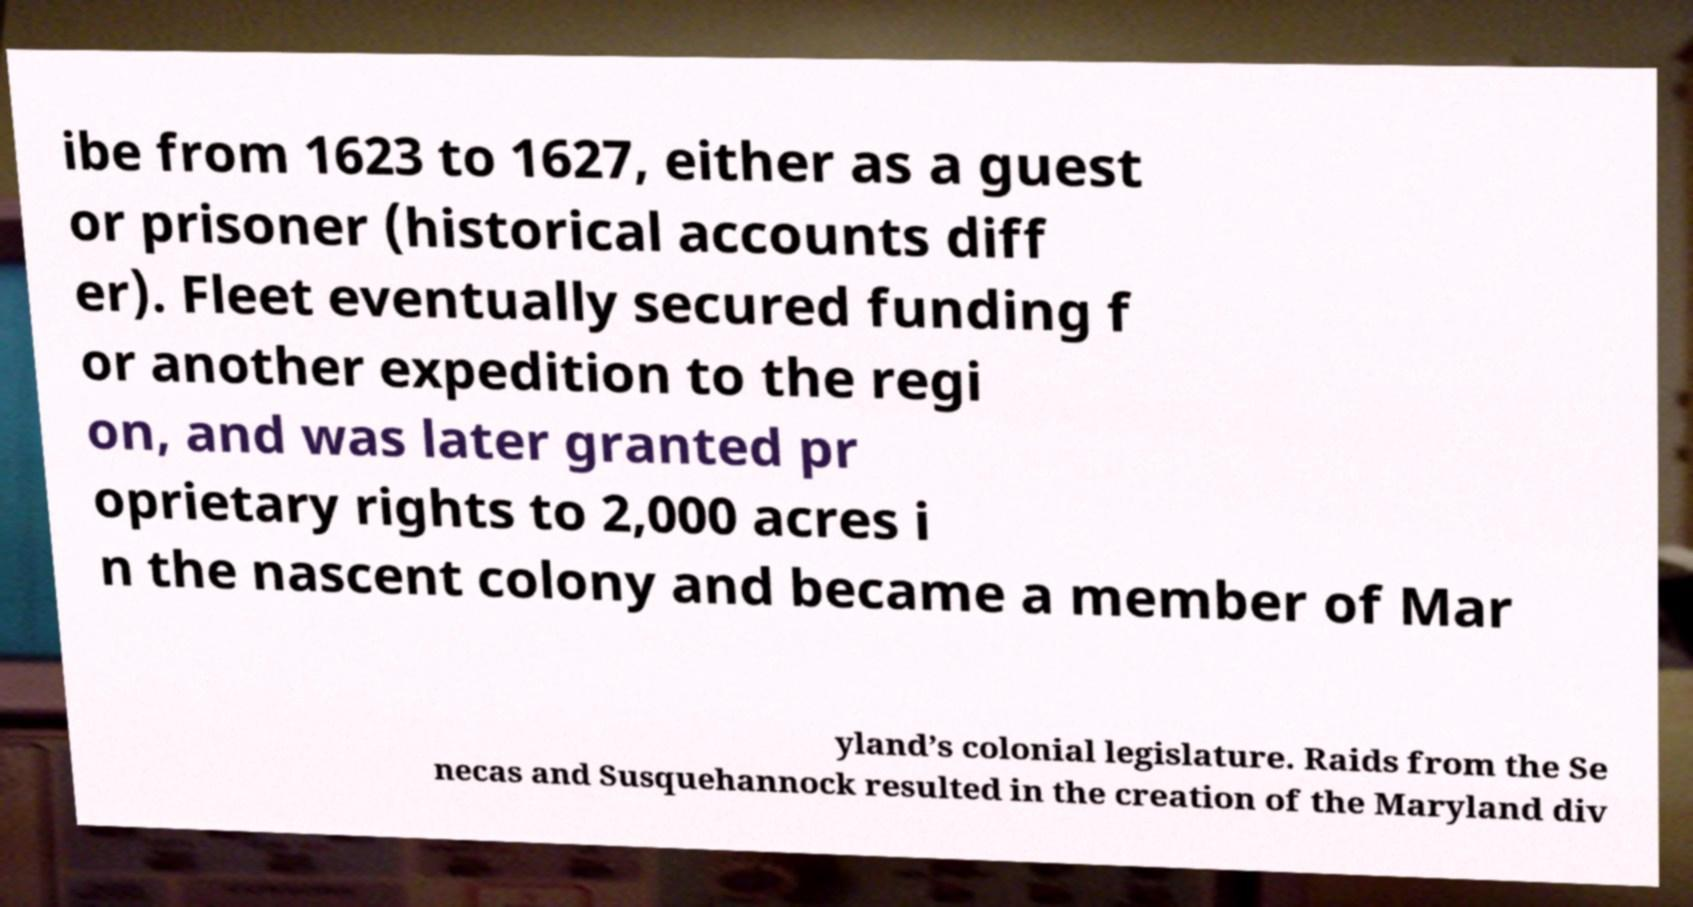I need the written content from this picture converted into text. Can you do that? ibe from 1623 to 1627, either as a guest or prisoner (historical accounts diff er). Fleet eventually secured funding f or another expedition to the regi on, and was later granted pr oprietary rights to 2,000 acres i n the nascent colony and became a member of Mar yland’s colonial legislature. Raids from the Se necas and Susquehannock resulted in the creation of the Maryland div 